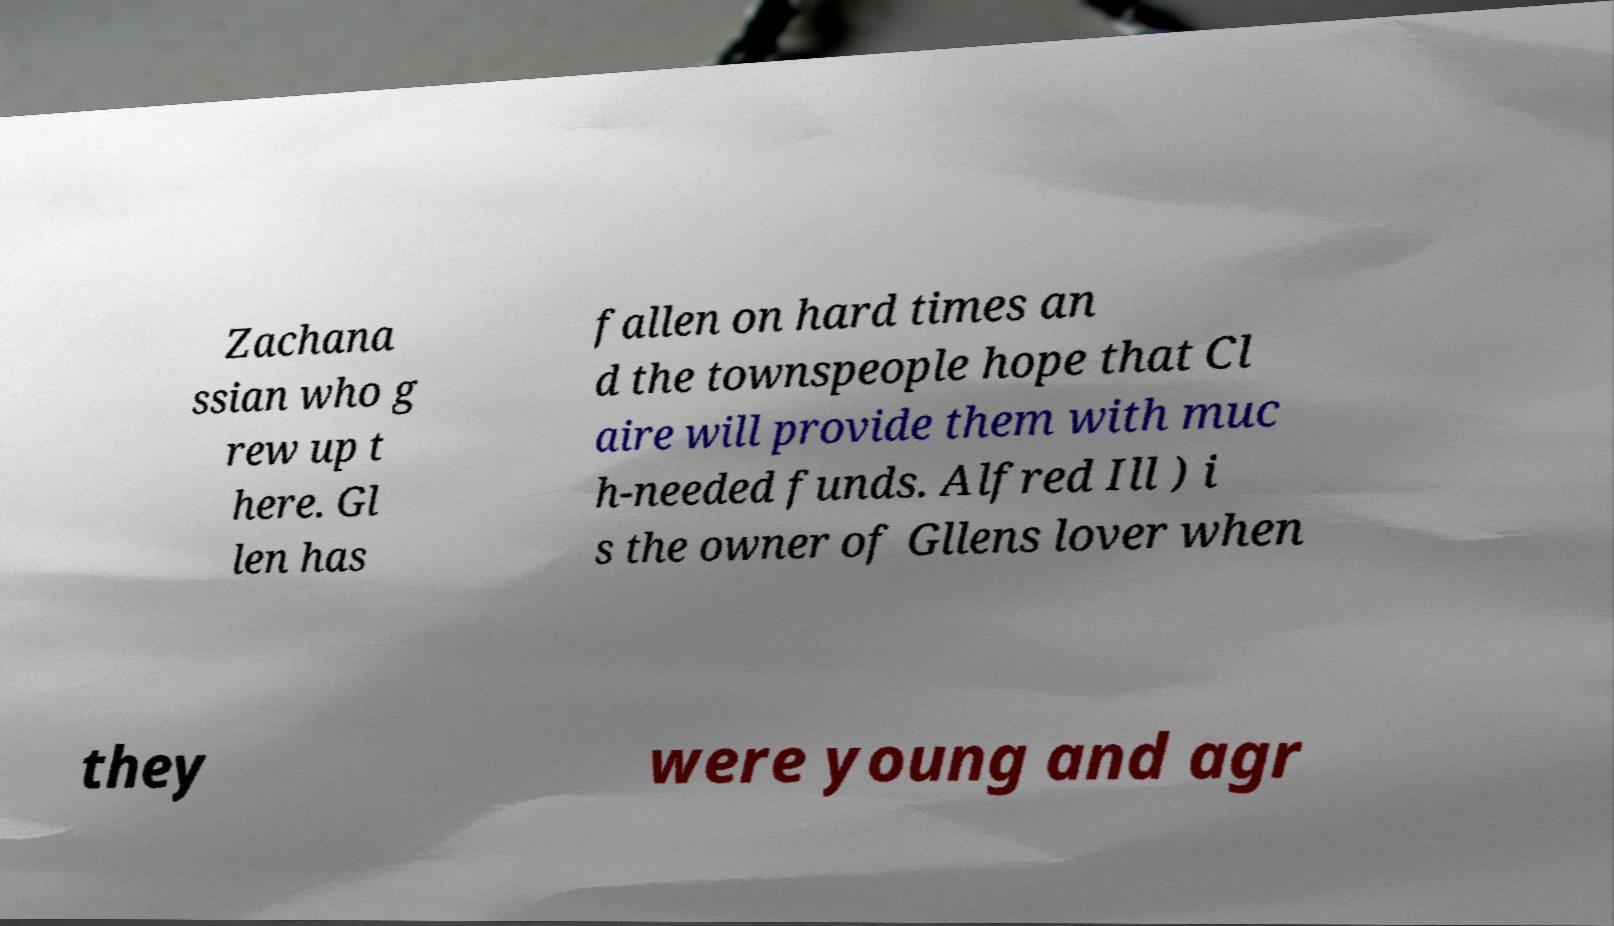Can you accurately transcribe the text from the provided image for me? Zachana ssian who g rew up t here. Gl len has fallen on hard times an d the townspeople hope that Cl aire will provide them with muc h-needed funds. Alfred Ill ) i s the owner of Gllens lover when they were young and agr 